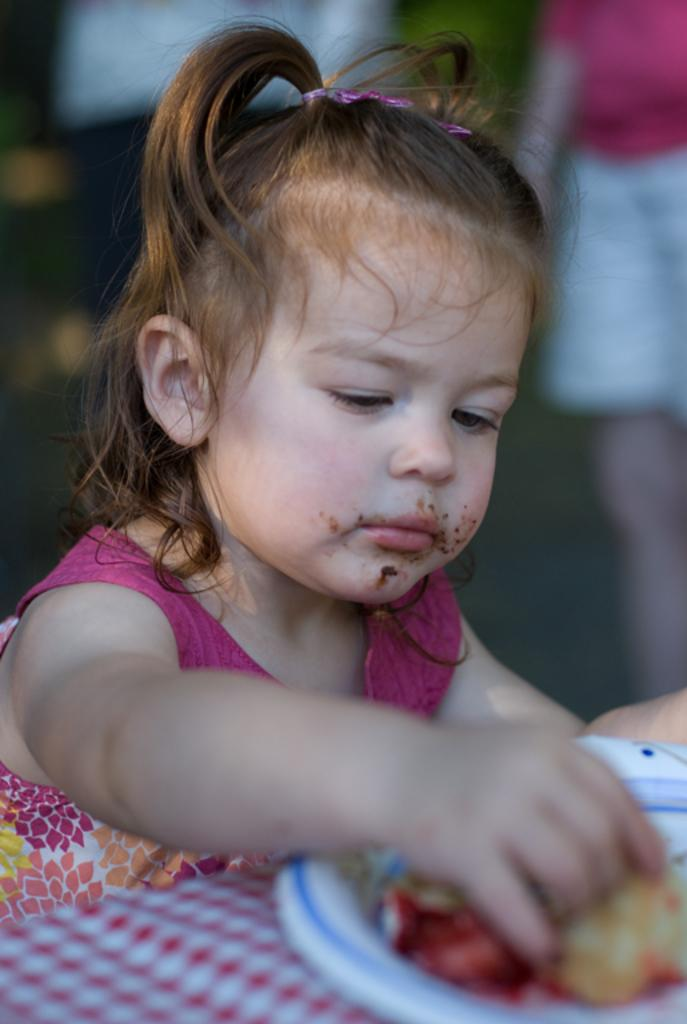What is the girl in the image doing? The girl is sitting in the image. What is located at the bottom of the image? There is a table at the bottom of the image. What is on the table in the image? There is a plate containing food on the table. What can be seen in the background of the image? There are people in the background of the image. How many lizards are running towards the north in the image? There are no lizards or any indication of direction in the image. 